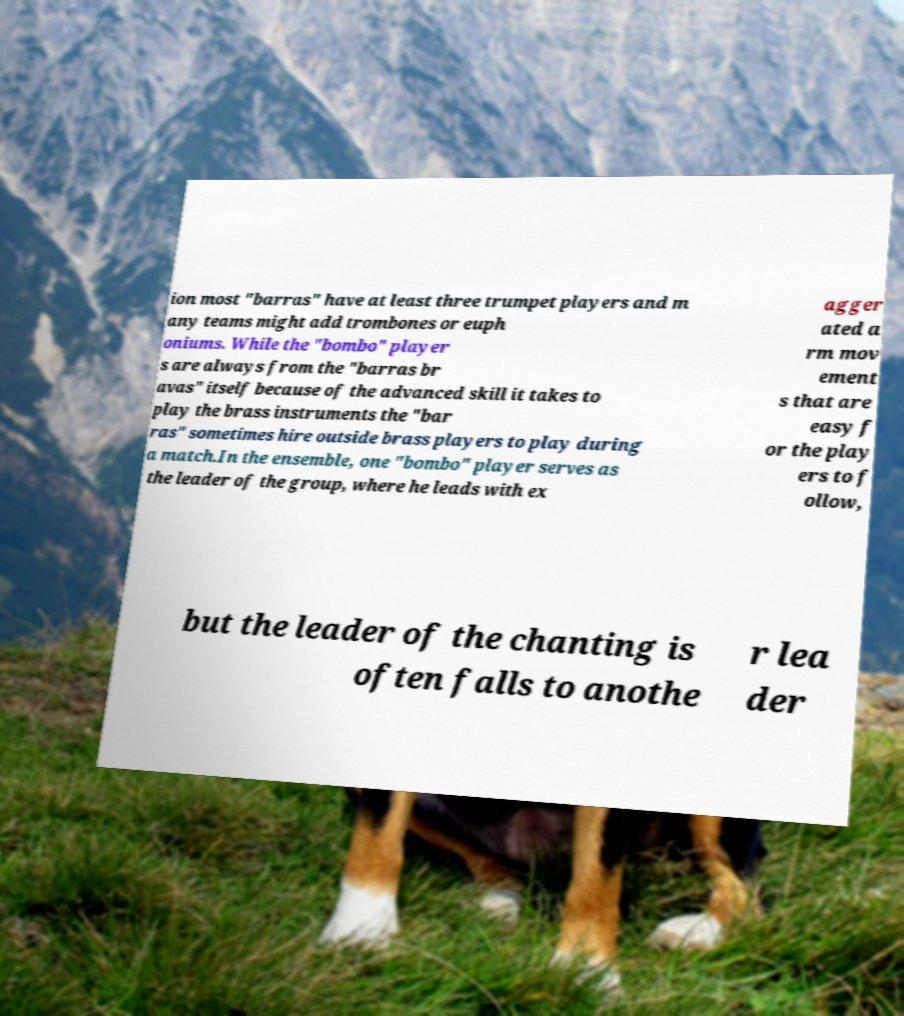Can you read and provide the text displayed in the image?This photo seems to have some interesting text. Can you extract and type it out for me? ion most "barras" have at least three trumpet players and m any teams might add trombones or euph oniums. While the "bombo" player s are always from the "barras br avas" itself because of the advanced skill it takes to play the brass instruments the "bar ras" sometimes hire outside brass players to play during a match.In the ensemble, one "bombo" player serves as the leader of the group, where he leads with ex agger ated a rm mov ement s that are easy f or the play ers to f ollow, but the leader of the chanting is often falls to anothe r lea der 